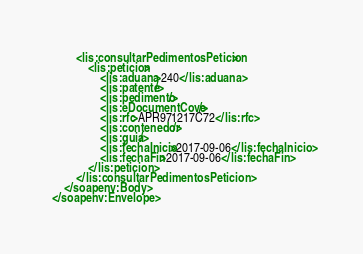<code> <loc_0><loc_0><loc_500><loc_500><_XML_>		<lis:consultarPedimentosPeticion>
			<lis:peticion>
				<lis:aduana>240</lis:aduana>
			 	<lis:patente/>
			 	<lis:pedimento/>
			 	<lis:eDocumentCove/>
			 	<lis:rfc>APR971217C72</lis:rfc>
			 	<lis:contenedor/>
			 	<lis:guia/>
			 	<lis:fechaInicio>2017-09-06</lis:fechaInicio>
			 	<lis:fechaFin>2017-09-06</lis:fechaFin>
		 	</lis:peticion>
		</lis:consultarPedimentosPeticion>
	</soapenv:Body>
</soapenv:Envelope>
</code> 